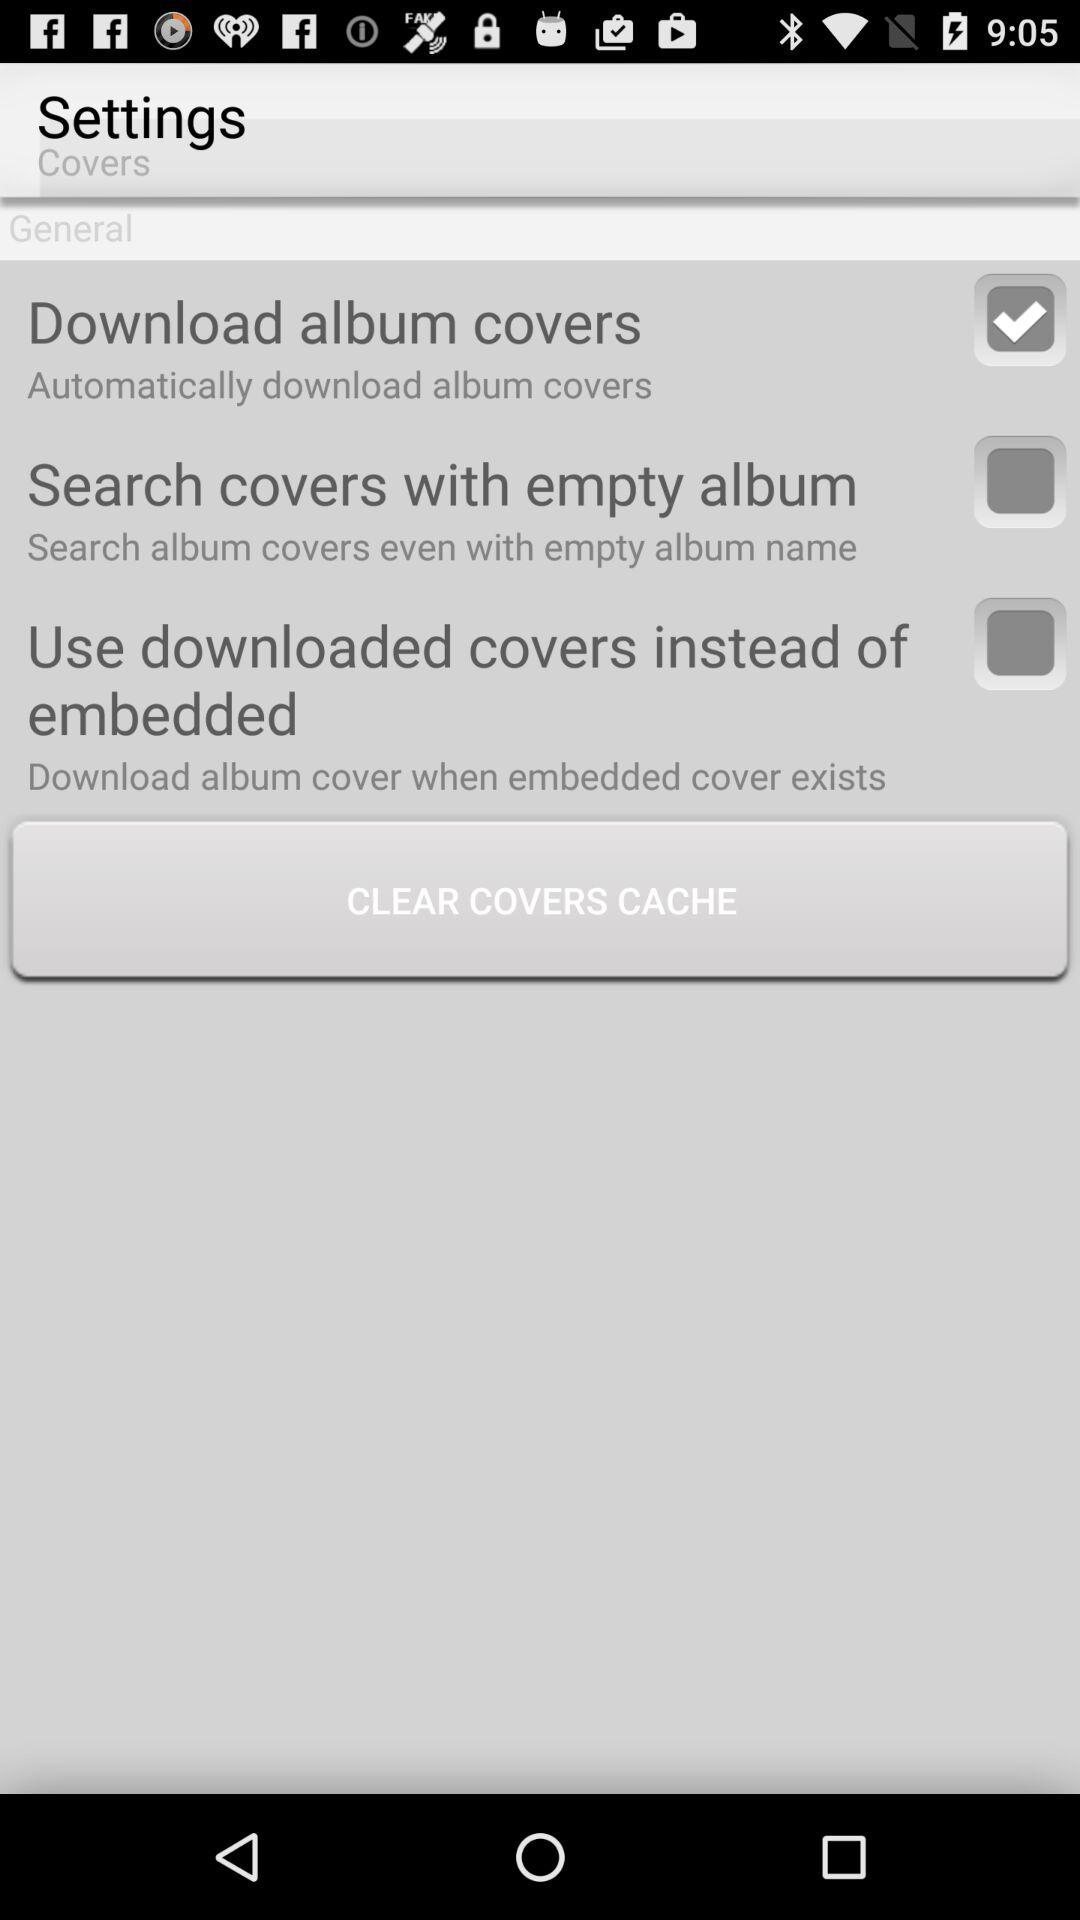What is the status of "Download album covers"? The status of "Download album covers" is "on". 